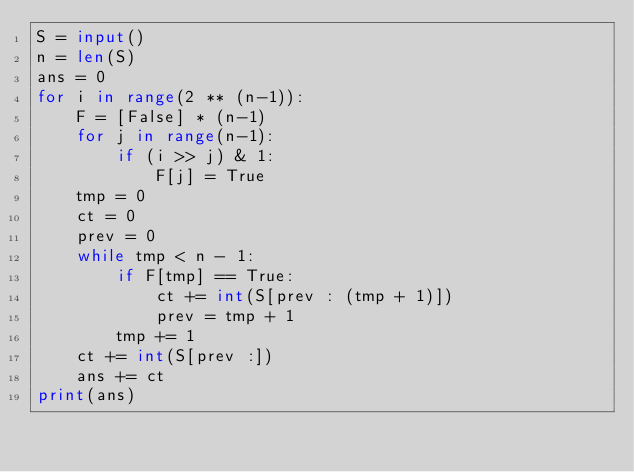Convert code to text. <code><loc_0><loc_0><loc_500><loc_500><_Python_>S = input()
n = len(S)
ans = 0
for i in range(2 ** (n-1)):
    F = [False] * (n-1)
    for j in range(n-1):
        if (i >> j) & 1:
            F[j] = True
    tmp = 0
    ct = 0
    prev = 0
    while tmp < n - 1:
        if F[tmp] == True:
            ct += int(S[prev : (tmp + 1)])
            prev = tmp + 1    
        tmp += 1
    ct += int(S[prev :])
    ans += ct
print(ans)</code> 